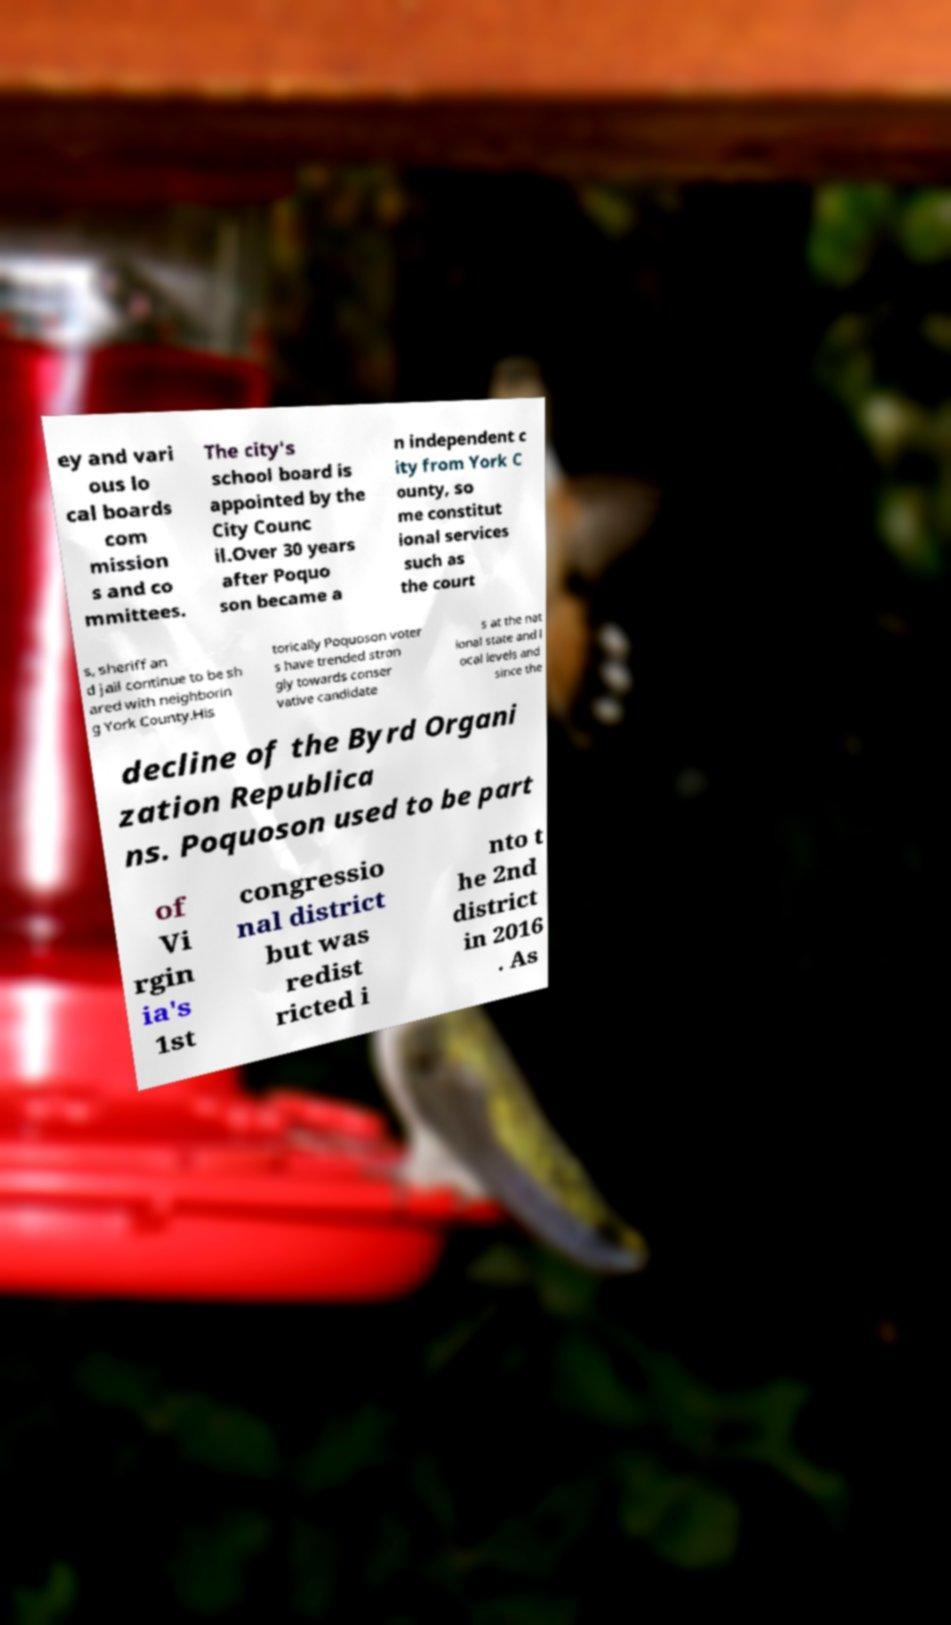What messages or text are displayed in this image? I need them in a readable, typed format. ey and vari ous lo cal boards com mission s and co mmittees. The city's school board is appointed by the City Counc il.Over 30 years after Poquo son became a n independent c ity from York C ounty, so me constitut ional services such as the court s, sheriff an d jail continue to be sh ared with neighborin g York County.His torically Poquoson voter s have trended stron gly towards conser vative candidate s at the nat ional state and l ocal levels and since the decline of the Byrd Organi zation Republica ns. Poquoson used to be part of Vi rgin ia's 1st congressio nal district but was redist ricted i nto t he 2nd district in 2016 . As 